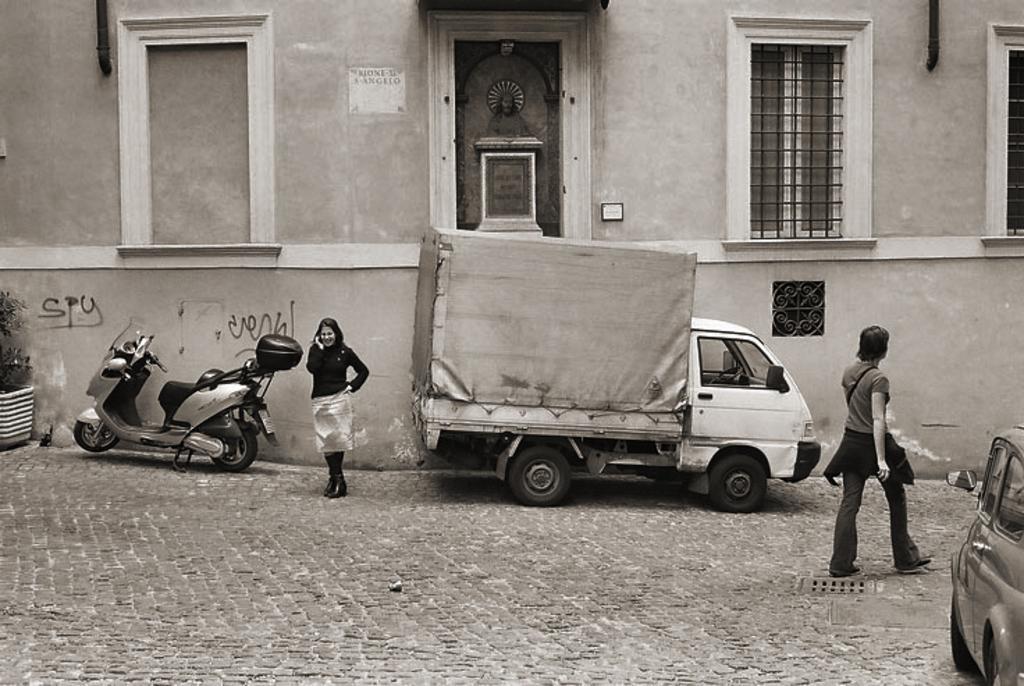How would you summarize this image in a sentence or two? In this image in front there are two persons standing on the road and we can see vehicles parked on the road. On the backside of the image there is a building with the window. At the center of the image there is a statue. In front of the building there is a flower pot. 